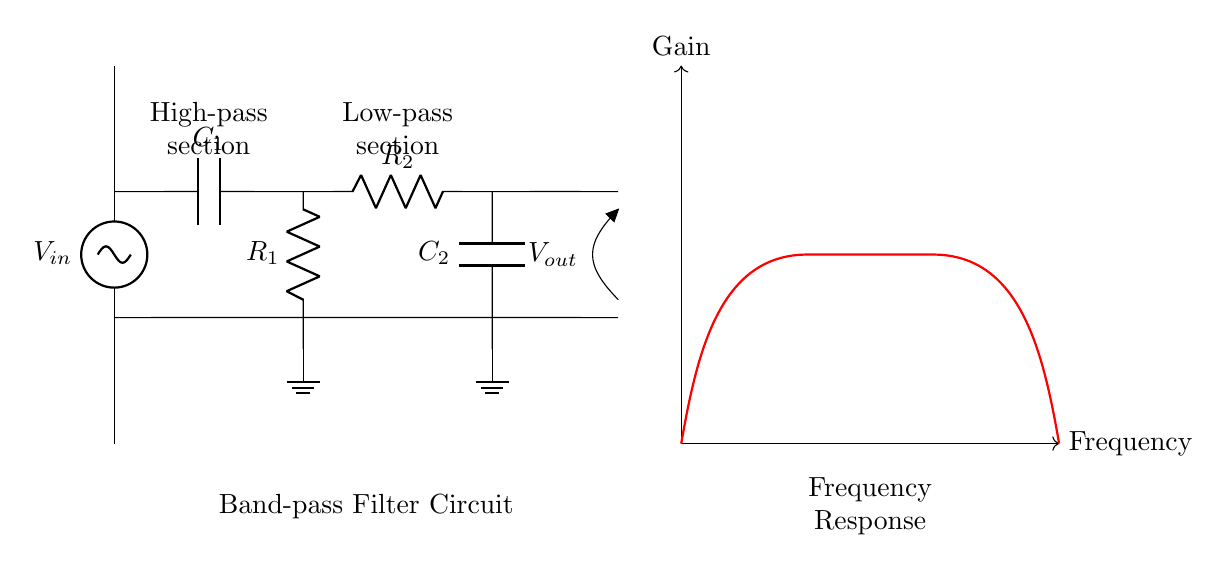What is the input voltage labeled as in the circuit? The input voltage is labeled as \( V_{in} \) in the circuit diagram, which is specifically identified at the top left of the diagram.
Answer: V in What type of components are used in the high-pass filter section? The high-pass filter section includes a capacitor labeled \( C_1 \) and a resistor labeled \( R_1 \). The arrangement of these components allows the circuit to pass high-frequency signals while attenuating low-frequency signals.
Answer: Capacitor and Resistor What is the output voltage labeled as? The output voltage is labeled as \( V_{out} \), which indicates the voltage signal that comes out of the circuit after processing the input signal through the filter sections.
Answer: V out Which section comes before the low-pass filter section? The high-pass filter section comes before the low-pass filter section as per the arrangement of components from left to right.
Answer: High-pass filter What is the purpose of this band-pass filter circuit? The band-pass filter circuit is designed to isolate specific frequency ranges from the input signals, allowing signals within a certain frequency band to pass while attenuating frequencies outside this range.
Answer: Isolate frequency ranges What is the gain response shape for the circuit shown? The gain response for the band-pass filter circuit is shown to initially rise, peak at a specific frequency, and then drop off, creating a typical bell-shaped response indicating the passband.
Answer: Bell-shaped response What components make up the low-pass filter section? The low-pass filter section consists of a resistor labeled \( R_2 \) and a capacitor labeled \( C_2 \), allowing the circuit to pass low-frequency signals while attenuating high-frequency signals.
Answer: Resistor and Capacitor 